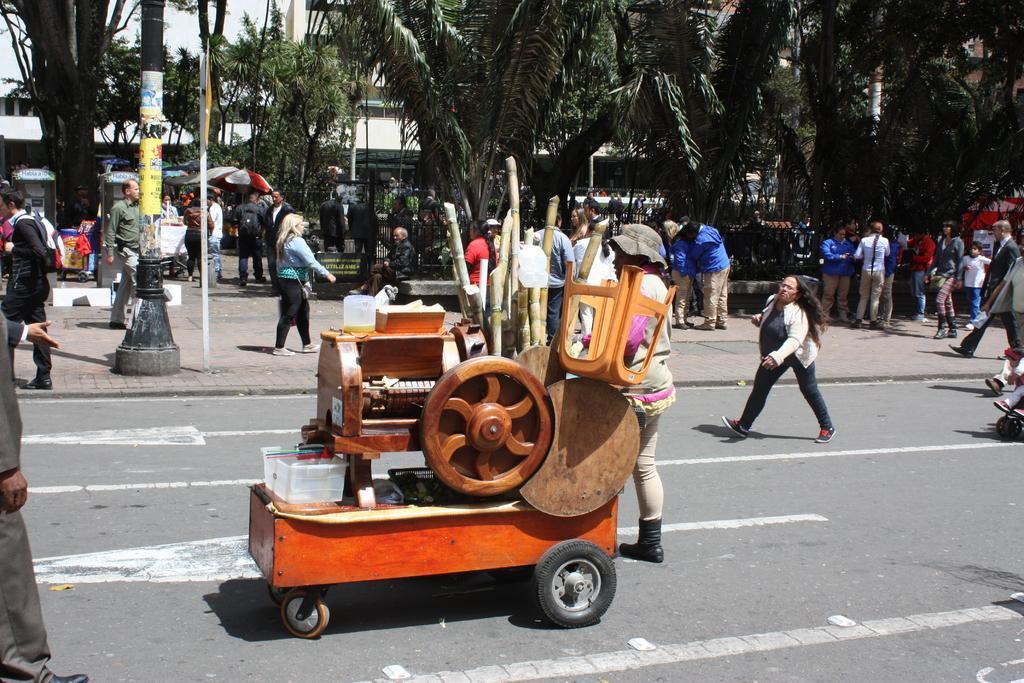Can you describe this image briefly? In this picture there is a sugarcane machine in the center of the image and there are people on the right and left side of the image, it seems to be the road side view, there are buildings and trees in the background area of the image. 